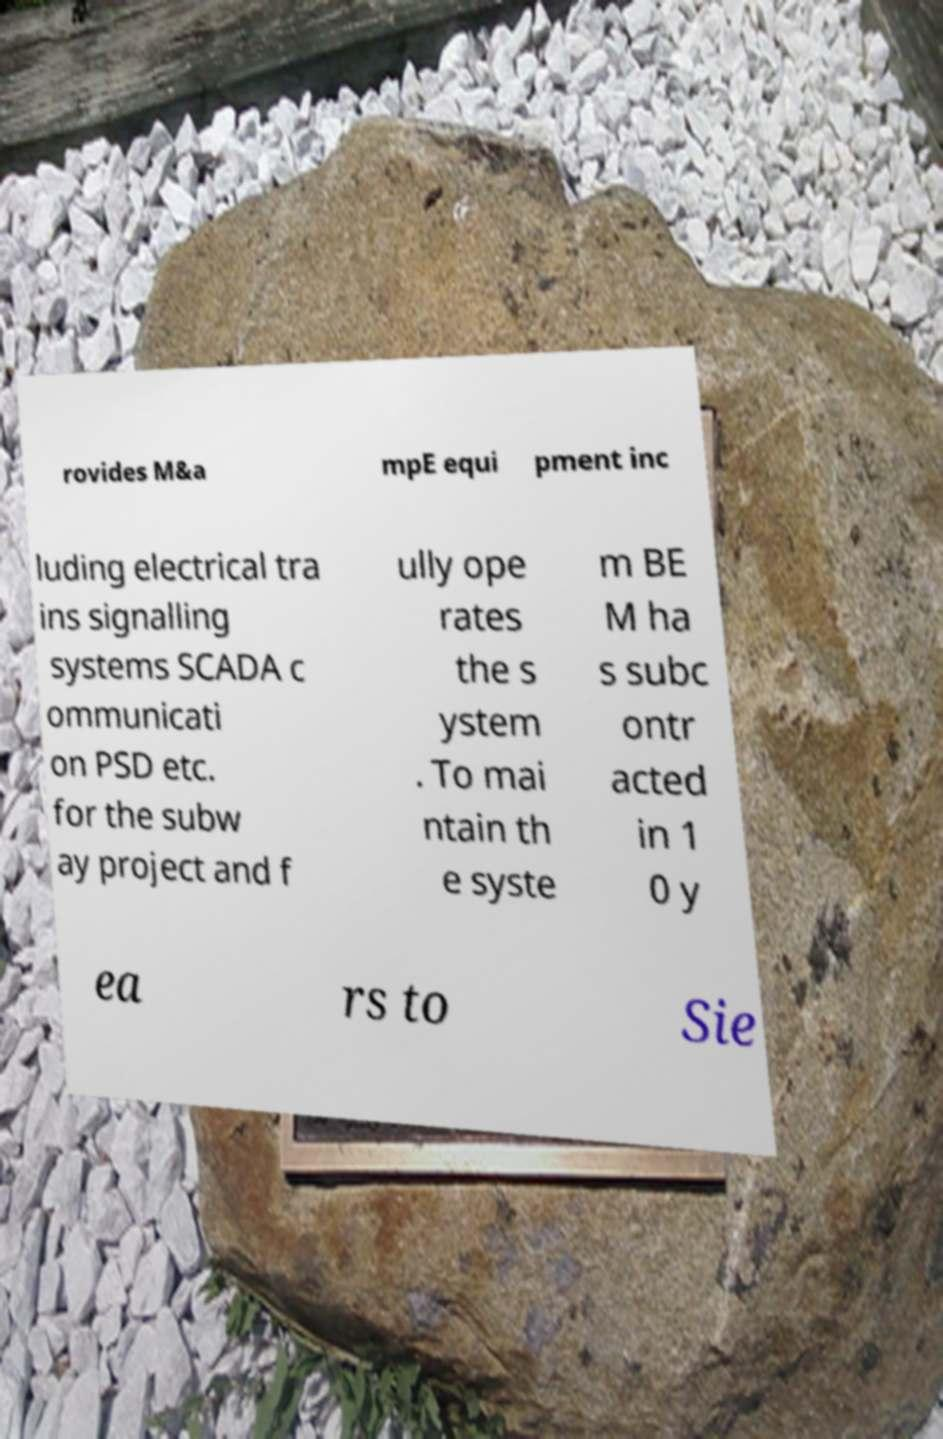Please identify and transcribe the text found in this image. rovides M&a mpE equi pment inc luding electrical tra ins signalling systems SCADA c ommunicati on PSD etc. for the subw ay project and f ully ope rates the s ystem . To mai ntain th e syste m BE M ha s subc ontr acted in 1 0 y ea rs to Sie 